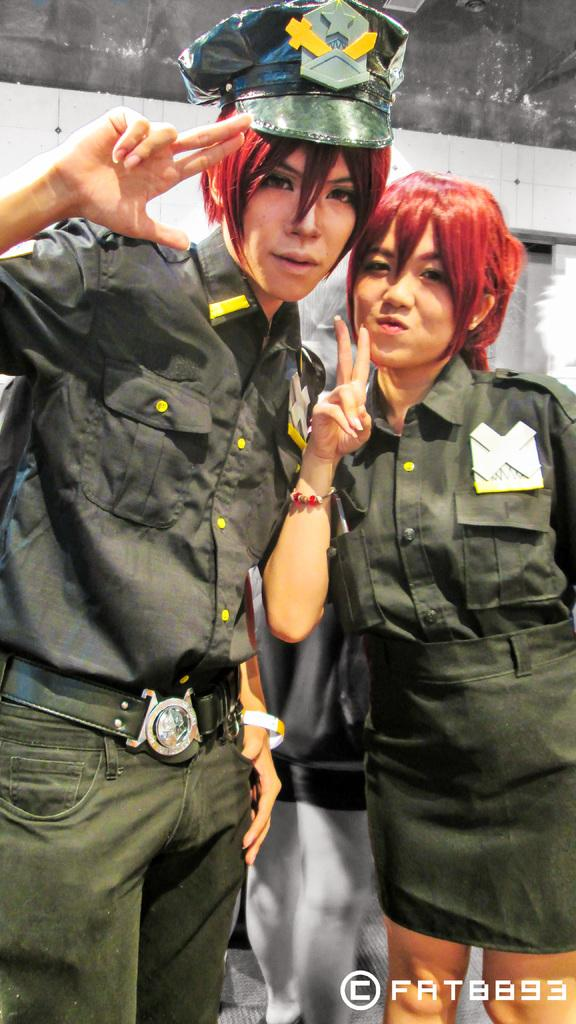What is the gender of the two people in the foreground of the picture? There is a man and a woman in the foreground of the picture. What is the woman wearing in the picture? The woman is wearing a green dress. What are the man and woman doing in the picture? The man and woman are standing and posing for a camera. What can be seen in the background of the picture? There is a wall and a person in the background of the picture. How many eyes can be seen on the wire in the image? There is no wire or eyes present in the image. 